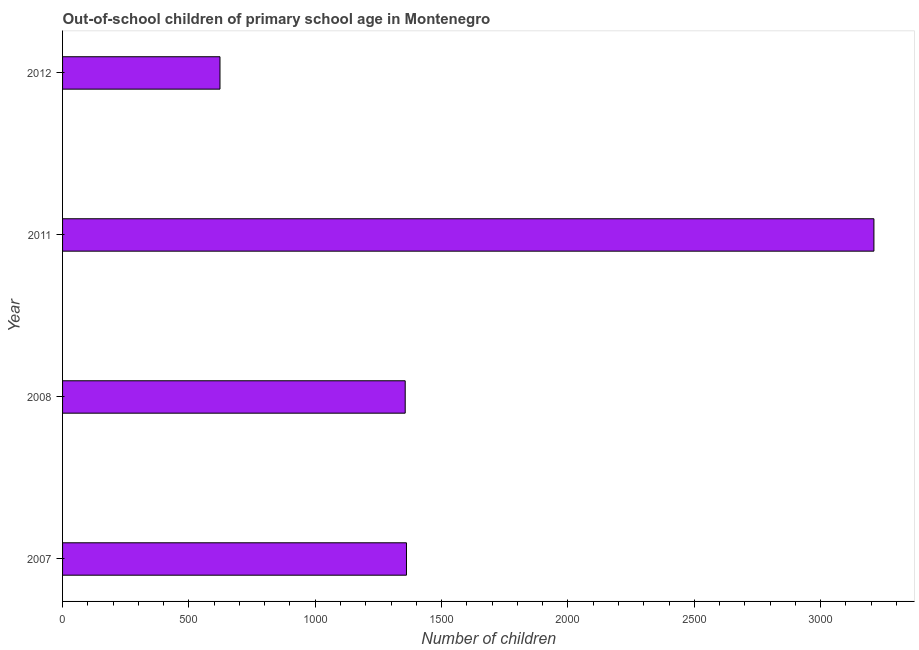Does the graph contain grids?
Ensure brevity in your answer.  No. What is the title of the graph?
Keep it short and to the point. Out-of-school children of primary school age in Montenegro. What is the label or title of the X-axis?
Provide a succinct answer. Number of children. What is the number of out-of-school children in 2011?
Your response must be concise. 3211. Across all years, what is the maximum number of out-of-school children?
Your answer should be very brief. 3211. Across all years, what is the minimum number of out-of-school children?
Keep it short and to the point. 623. In which year was the number of out-of-school children maximum?
Your answer should be very brief. 2011. What is the sum of the number of out-of-school children?
Your answer should be very brief. 6551. What is the difference between the number of out-of-school children in 2008 and 2011?
Make the answer very short. -1855. What is the average number of out-of-school children per year?
Provide a short and direct response. 1637. What is the median number of out-of-school children?
Your answer should be very brief. 1358.5. In how many years, is the number of out-of-school children greater than 1700 ?
Keep it short and to the point. 1. Do a majority of the years between 2011 and 2007 (inclusive) have number of out-of-school children greater than 1900 ?
Ensure brevity in your answer.  Yes. What is the ratio of the number of out-of-school children in 2008 to that in 2012?
Make the answer very short. 2.18. Is the difference between the number of out-of-school children in 2007 and 2008 greater than the difference between any two years?
Offer a very short reply. No. What is the difference between the highest and the second highest number of out-of-school children?
Your answer should be very brief. 1850. What is the difference between the highest and the lowest number of out-of-school children?
Provide a short and direct response. 2588. In how many years, is the number of out-of-school children greater than the average number of out-of-school children taken over all years?
Your answer should be very brief. 1. How many years are there in the graph?
Provide a succinct answer. 4. Are the values on the major ticks of X-axis written in scientific E-notation?
Your answer should be very brief. No. What is the Number of children in 2007?
Ensure brevity in your answer.  1361. What is the Number of children of 2008?
Provide a short and direct response. 1356. What is the Number of children in 2011?
Offer a terse response. 3211. What is the Number of children of 2012?
Give a very brief answer. 623. What is the difference between the Number of children in 2007 and 2011?
Offer a very short reply. -1850. What is the difference between the Number of children in 2007 and 2012?
Give a very brief answer. 738. What is the difference between the Number of children in 2008 and 2011?
Your answer should be very brief. -1855. What is the difference between the Number of children in 2008 and 2012?
Your response must be concise. 733. What is the difference between the Number of children in 2011 and 2012?
Ensure brevity in your answer.  2588. What is the ratio of the Number of children in 2007 to that in 2011?
Provide a succinct answer. 0.42. What is the ratio of the Number of children in 2007 to that in 2012?
Offer a terse response. 2.19. What is the ratio of the Number of children in 2008 to that in 2011?
Provide a succinct answer. 0.42. What is the ratio of the Number of children in 2008 to that in 2012?
Make the answer very short. 2.18. What is the ratio of the Number of children in 2011 to that in 2012?
Provide a short and direct response. 5.15. 